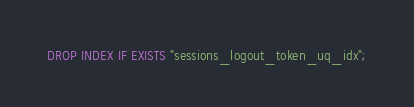Convert code to text. <code><loc_0><loc_0><loc_500><loc_500><_SQL_>DROP INDEX IF EXISTS "sessions_logout_token_uq_idx";</code> 